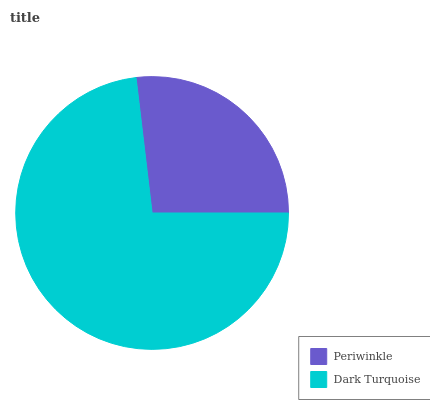Is Periwinkle the minimum?
Answer yes or no. Yes. Is Dark Turquoise the maximum?
Answer yes or no. Yes. Is Dark Turquoise the minimum?
Answer yes or no. No. Is Dark Turquoise greater than Periwinkle?
Answer yes or no. Yes. Is Periwinkle less than Dark Turquoise?
Answer yes or no. Yes. Is Periwinkle greater than Dark Turquoise?
Answer yes or no. No. Is Dark Turquoise less than Periwinkle?
Answer yes or no. No. Is Dark Turquoise the high median?
Answer yes or no. Yes. Is Periwinkle the low median?
Answer yes or no. Yes. Is Periwinkle the high median?
Answer yes or no. No. Is Dark Turquoise the low median?
Answer yes or no. No. 